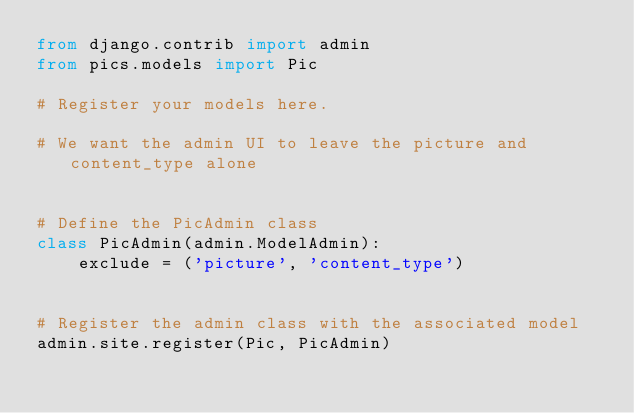Convert code to text. <code><loc_0><loc_0><loc_500><loc_500><_Python_>from django.contrib import admin
from pics.models import Pic

# Register your models here.

# We want the admin UI to leave the picture and content_type alone


# Define the PicAdmin class
class PicAdmin(admin.ModelAdmin):
    exclude = ('picture', 'content_type')


# Register the admin class with the associated model
admin.site.register(Pic, PicAdmin)
</code> 